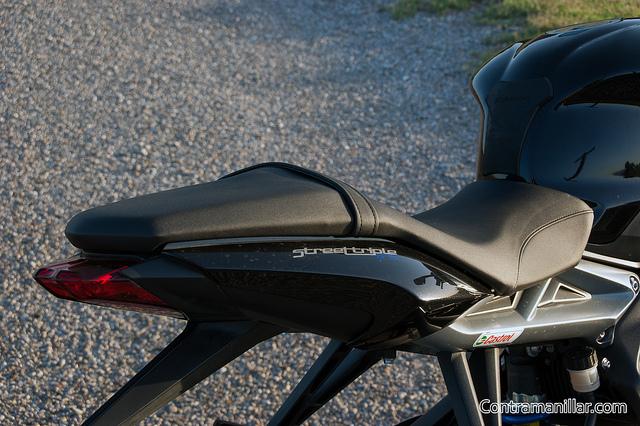Does the paint have a gloss or matte finish?
Write a very short answer. Gloss. What vehicle is there?
Quick response, please. Motorcycle. Is this a new bike?
Short answer required. Yes. 